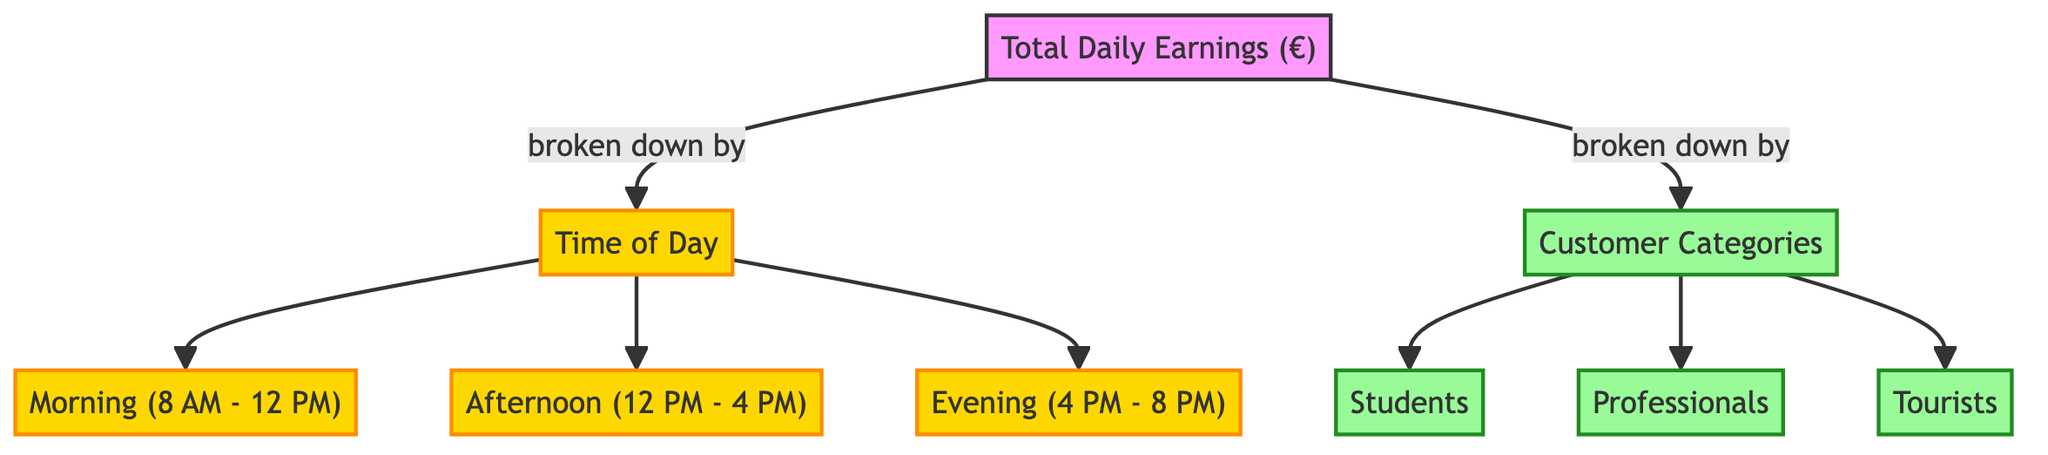What's the total number of time segments in the diagram? The diagram defines three distinct time segments related to daily cafe operations: morning, afternoon, and evening. This can be counted by checking the nodes classified under 'time of day.'
Answer: 3 What are the three customer categories represented in the diagram? The diagram specifies three customer categories: students, professionals, and tourists. These can be found in the 'customer categories' node of the diagram.
Answer: students, professionals, tourists Which time segment comes first in the daily breakdown? The diagram outlines the order of time segments, with 'Morning (8 AM - 12 PM)' appearing as the first time period. This can be confirmed by examining the connections from the 'time of day' node.
Answer: Morning (8 AM - 12 PM) How many nodes are there under customer categories? There are three nodes listed under customer categories: students, professionals, and tourists. These nodes can be counted directly in the 'customer categories' part of the diagram.
Answer: 3 Which time segment does the 'Evening (4 PM - 8 PM)' node directly connect to? The 'Evening (4 PM - 8 PM)' node is connected under the 'time of day' node, which indicates it pertains specifically to the evening period in the daily earnings breakdown.
Answer: time of day If the total earnings need to be analyzed, which two categories is it broken down into? The total daily earnings node is broken down into two categories: time of day and customer categories. These categories are the direct connections from the 'total daily earnings' node.
Answer: time of day and customer categories 